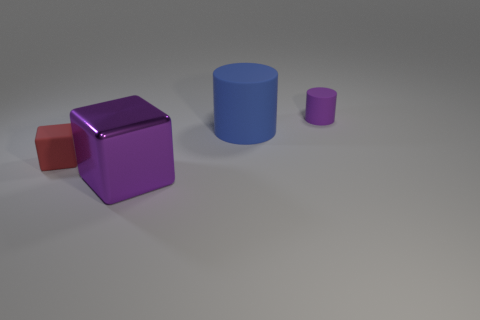Add 1 small red metal spheres. How many objects exist? 5 Subtract 0 brown balls. How many objects are left? 4 Subtract all shiny things. Subtract all big blue things. How many objects are left? 2 Add 4 big metallic things. How many big metallic things are left? 5 Add 1 big purple rubber balls. How many big purple rubber balls exist? 1 